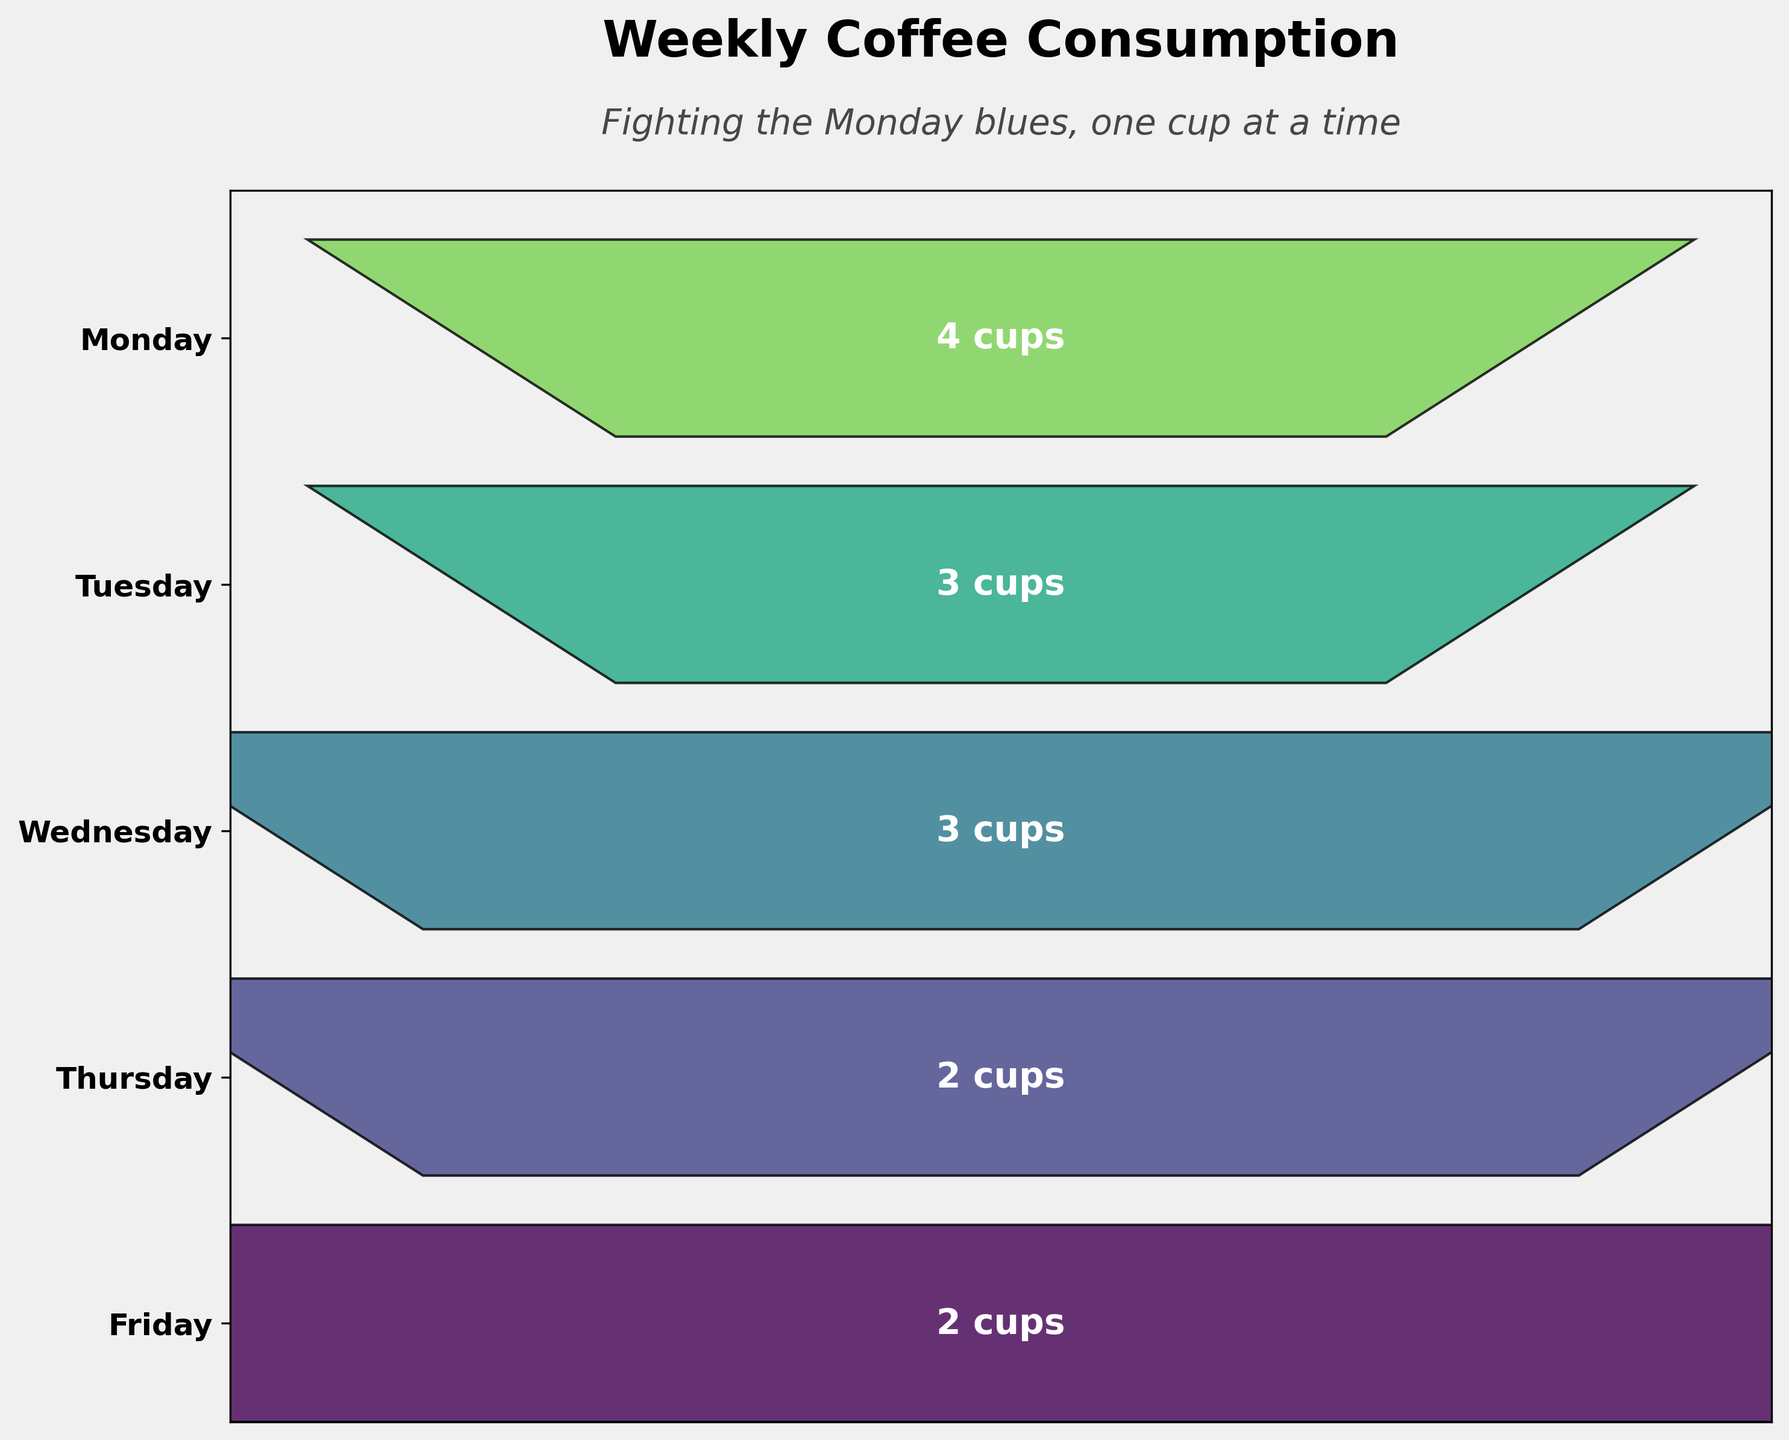What is the title of the figure? The title of the figure is typically placed at the top center and is identifiable as the main heading.
Answer: Weekly Coffee Consumption How many cups of coffee were consumed on Wednesday? Locate Wednesday on the y-axis, then read the number of cups associated with it in the funnel chart.
Answer: 3 cups What is the subtitle of the figure? The subtitle is generally placed below the main title and provides additional context.
Answer: Fighting the Monday blues, one cup at a time What is the difference in coffee consumption between Monday and Thursday? Look at the number of cups consumed on Monday and Thursday and calculate their difference: 4 cups (Monday) - 2 cups (Thursday).
Answer: 2 cups Which day had the highest coffee consumption? Identify the day with the widest funnel section, which corresponds to the highest number of cups consumed.
Answer: Monday How many total cups of coffee were consumed from Monday to Friday? Sum the cups of coffee consumed each day: 4 (Mon) + 3 (Tue) + 3 (Wed) + 2 (Thu) + 2 (Fri) = 14 cups.
Answer: 14 cups How does the coffee consumption on Tuesday compare to Friday? Compare the width of the funnel sections for Tuesday and Friday; they represent 3 cups and 2 cups, respectively.
Answer: Tuesday had 1 more cup than Friday What is the average coffee consumption per day from Monday to Friday? Calculate the total number of cups consumed (14) and divide by the number of days (5): 14 cups / 5 days = 2.8 cups.
Answer: 2.8 cups What trend do you observe in coffee consumption from Monday to Friday? The funnel sections get progressively narrower, indicating a general decrease in coffee consumption as the week progresses.
Answer: Decreasing trend 